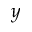Convert formula to latex. <formula><loc_0><loc_0><loc_500><loc_500>y</formula> 